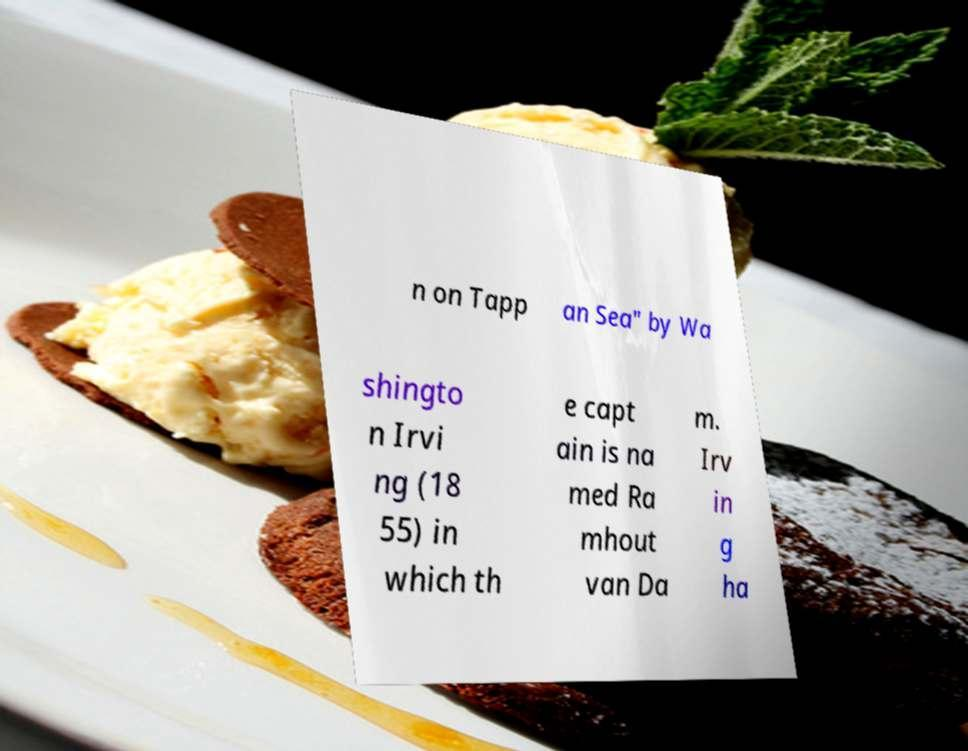Can you read and provide the text displayed in the image?This photo seems to have some interesting text. Can you extract and type it out for me? n on Tapp an Sea" by Wa shingto n Irvi ng (18 55) in which th e capt ain is na med Ra mhout van Da m. Irv in g ha 